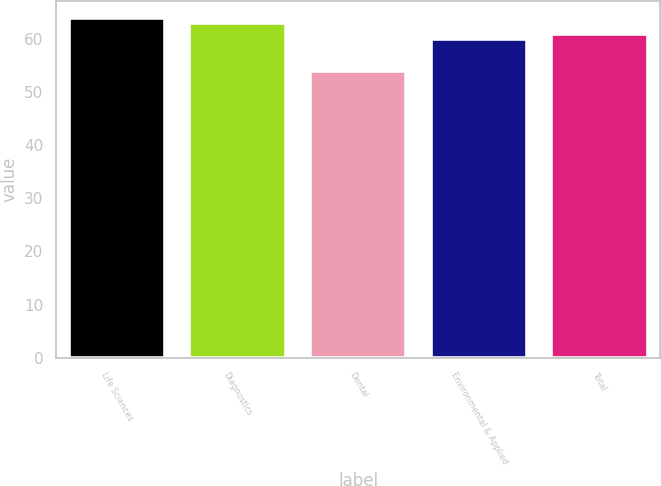Convert chart. <chart><loc_0><loc_0><loc_500><loc_500><bar_chart><fcel>Life Sciences<fcel>Diagnostics<fcel>Dental<fcel>Environmental & Applied<fcel>Total<nl><fcel>64<fcel>63<fcel>54<fcel>60<fcel>61<nl></chart> 